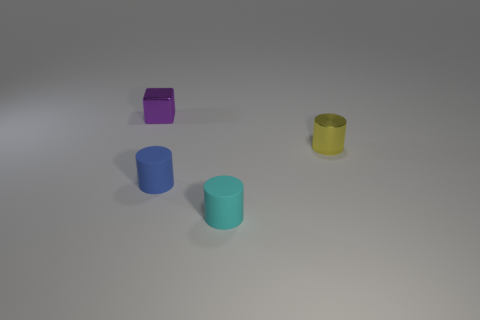Subtract all matte cylinders. How many cylinders are left? 1 Add 1 red matte spheres. How many objects exist? 5 Subtract all cubes. How many objects are left? 3 Subtract all red cylinders. How many cyan blocks are left? 0 Subtract all tiny rubber cylinders. Subtract all cyan rubber things. How many objects are left? 1 Add 2 blue rubber cylinders. How many blue rubber cylinders are left? 3 Add 4 blue rubber cylinders. How many blue rubber cylinders exist? 5 Subtract 0 gray cylinders. How many objects are left? 4 Subtract all brown blocks. Subtract all gray balls. How many blocks are left? 1 